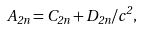<formula> <loc_0><loc_0><loc_500><loc_500>A _ { 2 n } = C _ { 2 n } + D _ { 2 n } / c ^ { 2 } ,</formula> 